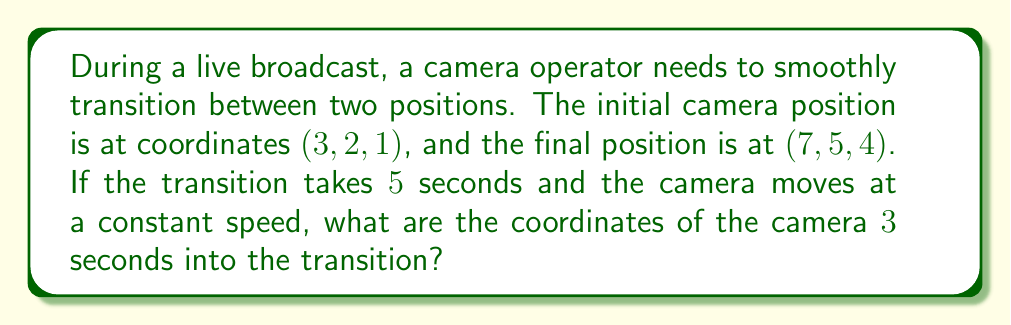Can you solve this math problem? To solve this problem, we need to use the concept of vector interpolation in a 3D coordinate system. Let's break it down step-by-step:

1. Identify the initial and final positions:
   Initial position: $P_1 = (3, 2, 1)$
   Final position: $P_2 = (7, 5, 4)$

2. Calculate the displacement vector:
   $\vec{v} = P_2 - P_1 = (7-3, 5-2, 4-1) = (4, 3, 3)$

3. Determine the fraction of the transition completed after 3 seconds:
   Total transition time = 5 seconds
   Time elapsed = 3 seconds
   Fraction completed = $\frac{3}{5} = 0.6$

4. Calculate the position vector at 3 seconds using linear interpolation:
   $P(t) = P_1 + t\vec{v}$, where $t$ is the fraction of the transition completed

   $P(0.6) = (3, 2, 1) + 0.6(4, 3, 3)$
   
   $P(0.6) = (3, 2, 1) + (2.4, 1.8, 1.8)$
   
   $P(0.6) = (5.4, 3.8, 2.8)$

5. Round the coordinates to one decimal place for practical camera positioning:
   Final position at 3 seconds: $(5.4, 3.8, 2.8)$

This solution demonstrates how to calculate the camera's position during a smooth transition, which is crucial for seamless on-air transitions in live broadcasts.
Answer: The coordinates of the camera 3 seconds into the transition are $(5.4, 3.8, 2.8)$. 